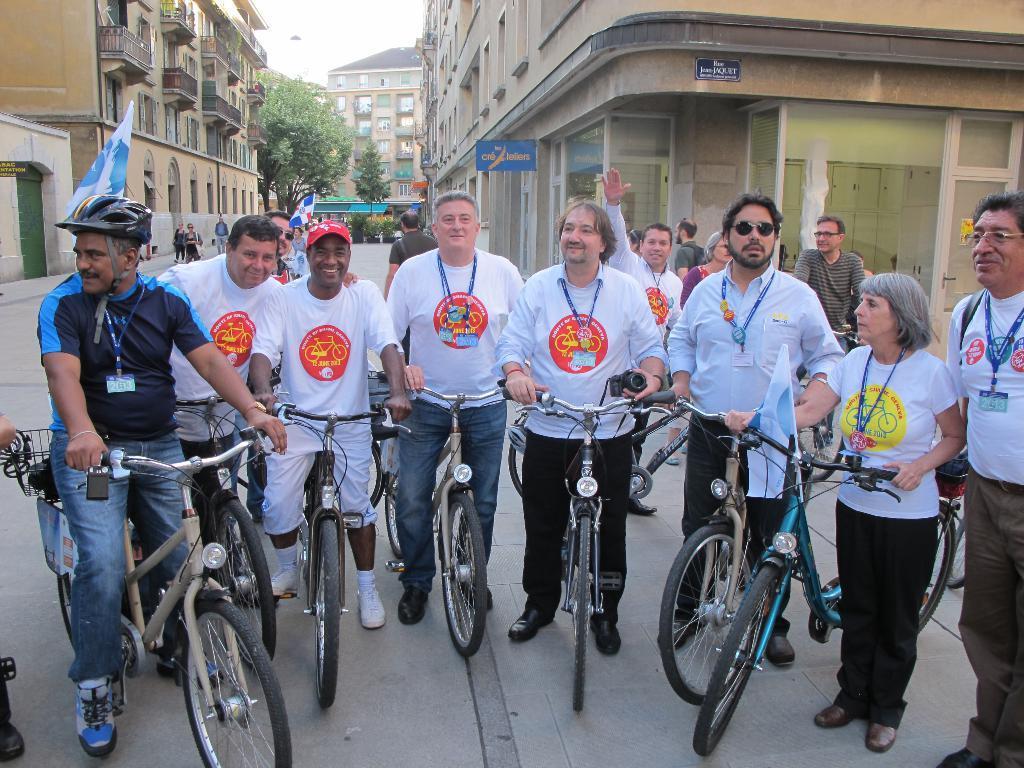Could you give a brief overview of what you see in this image? In the middle of the image few people are standing and holding bicycles. Behind them few people are standing and walking. At the top of the image we can see some buildings, trees and plants. Behind the buildings we can see the sky. 